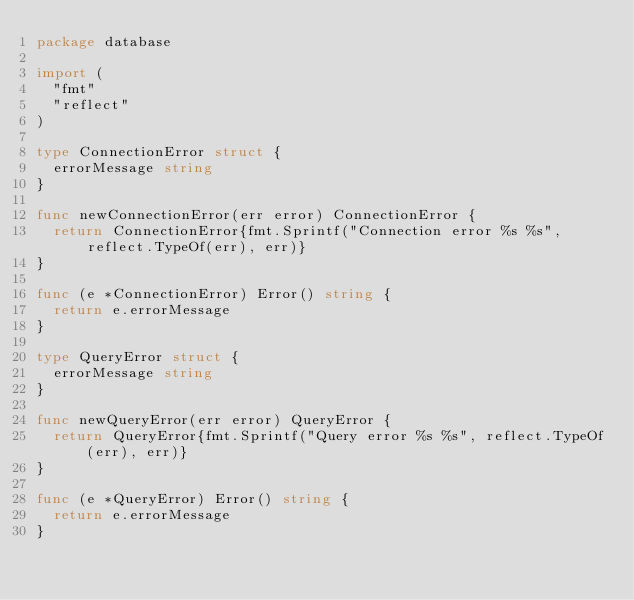<code> <loc_0><loc_0><loc_500><loc_500><_Go_>package database

import (
	"fmt"
	"reflect"
)

type ConnectionError struct {
	errorMessage string
}

func newConnectionError(err error) ConnectionError {
	return ConnectionError{fmt.Sprintf("Connection error %s %s", reflect.TypeOf(err), err)}
}

func (e *ConnectionError) Error() string {
	return e.errorMessage
}

type QueryError struct {
	errorMessage string
}

func newQueryError(err error) QueryError {
	return QueryError{fmt.Sprintf("Query error %s %s", reflect.TypeOf(err), err)}
}

func (e *QueryError) Error() string {
	return e.errorMessage
}
</code> 